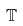<formula> <loc_0><loc_0><loc_500><loc_500>\mathbb { T }</formula> 